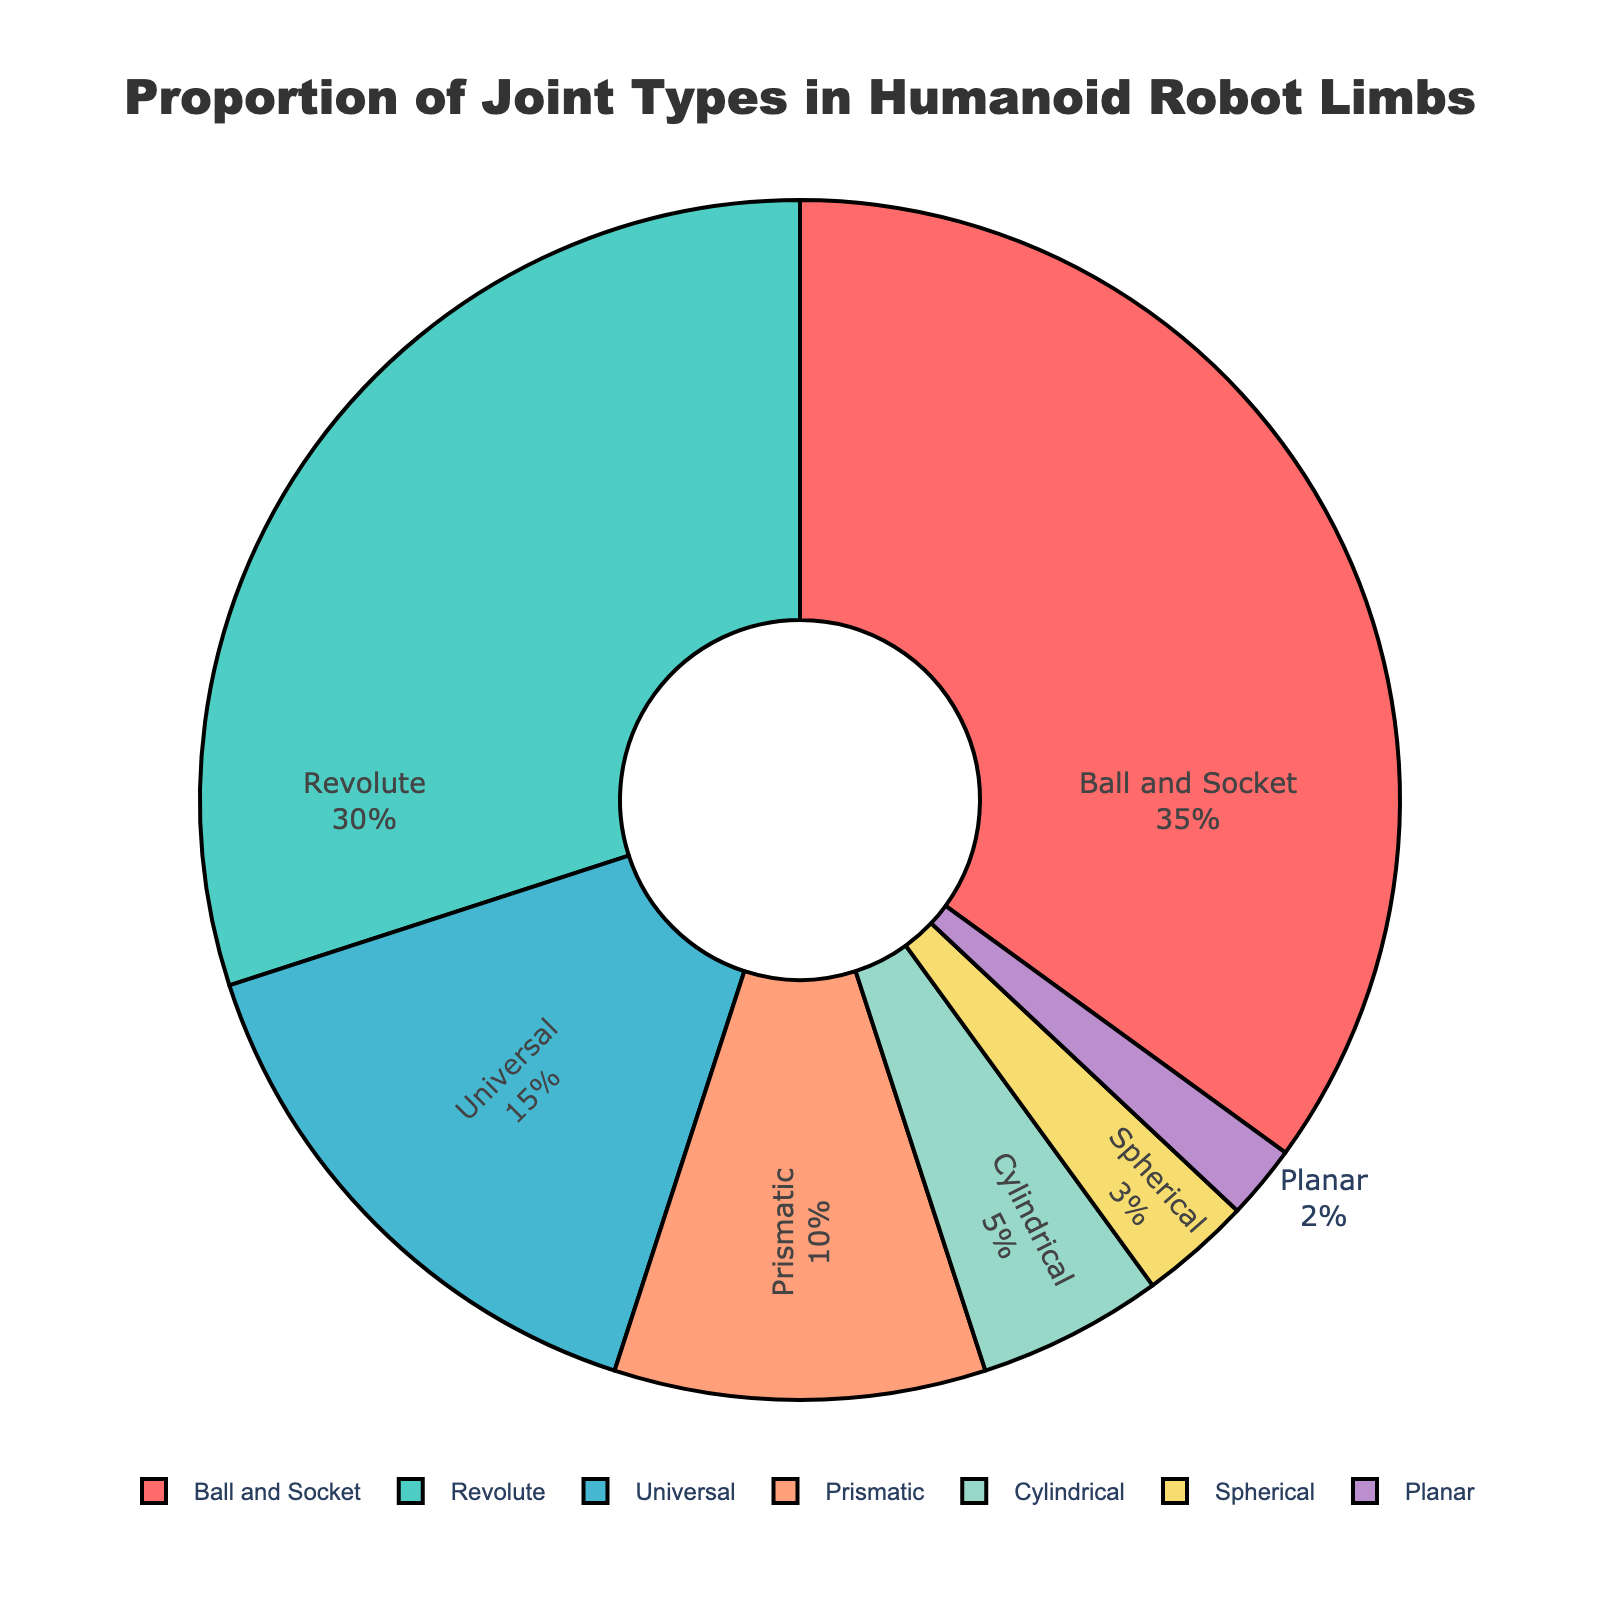Which joint type has the largest proportion in the pie chart? The pie chart shows that the largest segment corresponds to the "Ball and Socket" joint type, making up 35% of the total.
Answer: Ball and Socket Which joint type is represented by the smallest segment in the pie chart? The smallest segment in the pie chart corresponds to the "Planar" joint type, which makes up 2% of the total.
Answer: Planar How do the percentages of the Ball and Socket and Revolute joints compare? The Ball and Socket joint type makes up 35% of the total, while the Revolute joint type makes up 30%. Thus, Ball and Socket is 5% more than Revolute.
Answer: Ball and Socket is 5% more What is the combined percentage of Ball and Socket, Revolute, and Universal joints? The Ball and Socket joint is 35%, the Revolute joint is 30%, and the Universal joint is 15%. Adding these percentages together, 35 + 30 + 15 = 80%.
Answer: 80% Is the proportion of Prismatic joints greater than the proportion of Cylindrical joints? Yes, the Prismatic joint type makes up 10%, while the Cylindrical joint type makes up 5%. Therefore, Prismatic is greater than Cylindrical.
Answer: Yes What is the percentage difference between the joints with the second-highest and the least proportion? The Revolute joint type (second-highest) makes up 30%, and the Planar joint type (least) makes up 2%. The difference is 30 - 2 = 28%.
Answer: 28% Which joint types combined make up less than 10% of the total? The pie chart shows that the Cylindrical (5%), Spherical (3%), and Planar (2%) joints combined make up less than 10%. Their sum is 5 + 3 + 2 = 10%.
Answer: Cylindrical, Spherical, and Planar What is the visual representation color for the Universal joint type? The Universal joint type is visually represented by a shade of green.
Answer: Green How does the combined proportion of Prismatic and Cylindrical joints compare to Ball and Socket joints? The Prismatic joint is 10% and the Cylindrical joint is 5%, combined they are 10 + 5 = 15%. The Ball and Socket joint alone is 35%, so the combined Prismatic and Cylindrical joints are 20% less than Ball and Socket.
Answer: 20% less What is the average percentage of all joint types shown in the pie chart? The percentages of all joint types shown are: 35, 30, 15, 10, 5, 3, and 2. Summing these, we get 100. Dividing by the number of joint types (7), the average is 100 / 7 ≈ 14.29%.
Answer: 14.29% 